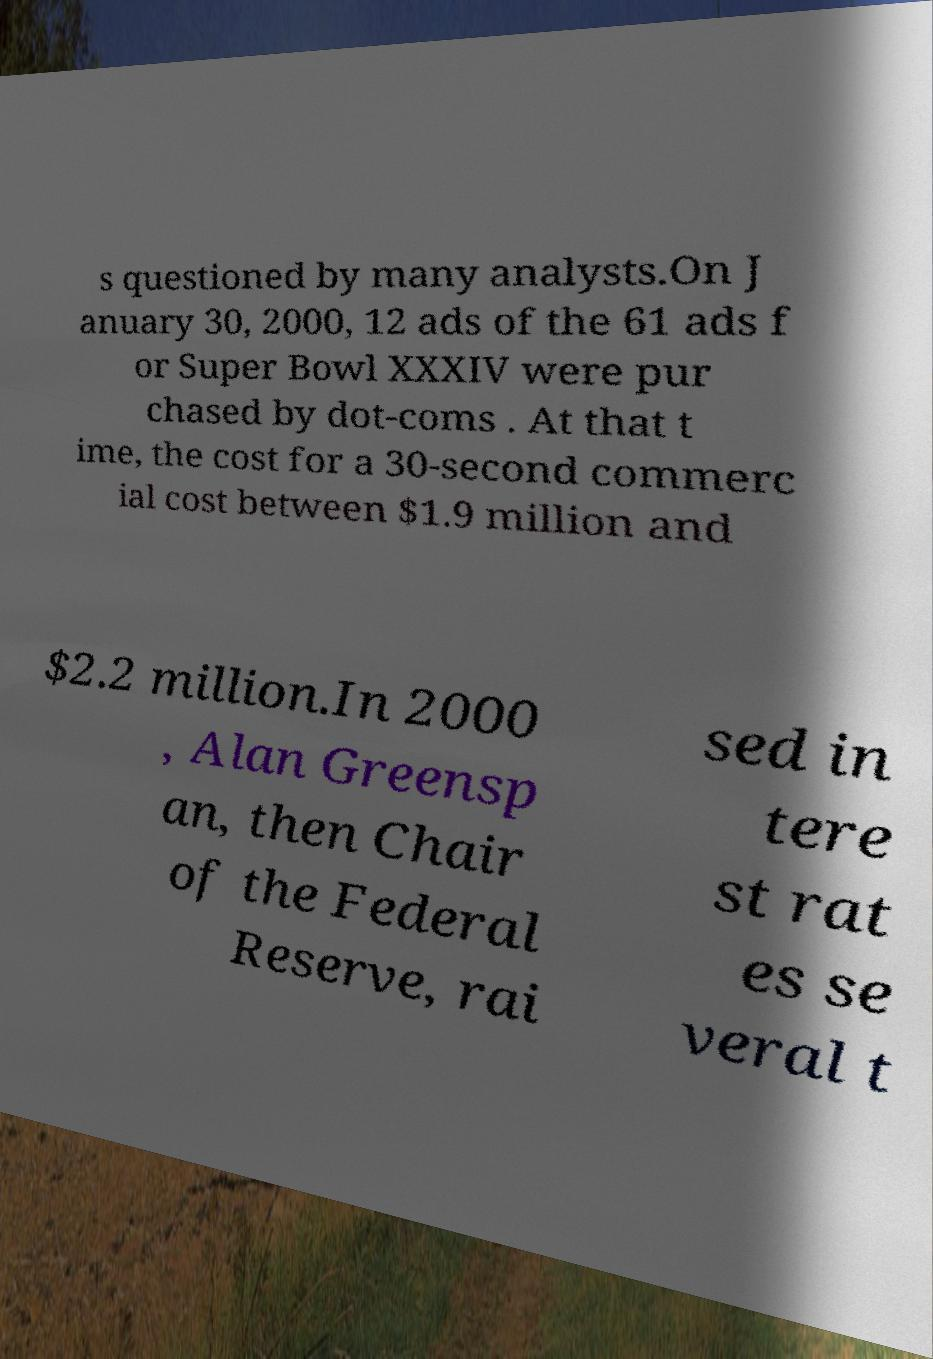For documentation purposes, I need the text within this image transcribed. Could you provide that? s questioned by many analysts.On J anuary 30, 2000, 12 ads of the 61 ads f or Super Bowl XXXIV were pur chased by dot-coms . At that t ime, the cost for a 30-second commerc ial cost between $1.9 million and $2.2 million.In 2000 , Alan Greensp an, then Chair of the Federal Reserve, rai sed in tere st rat es se veral t 